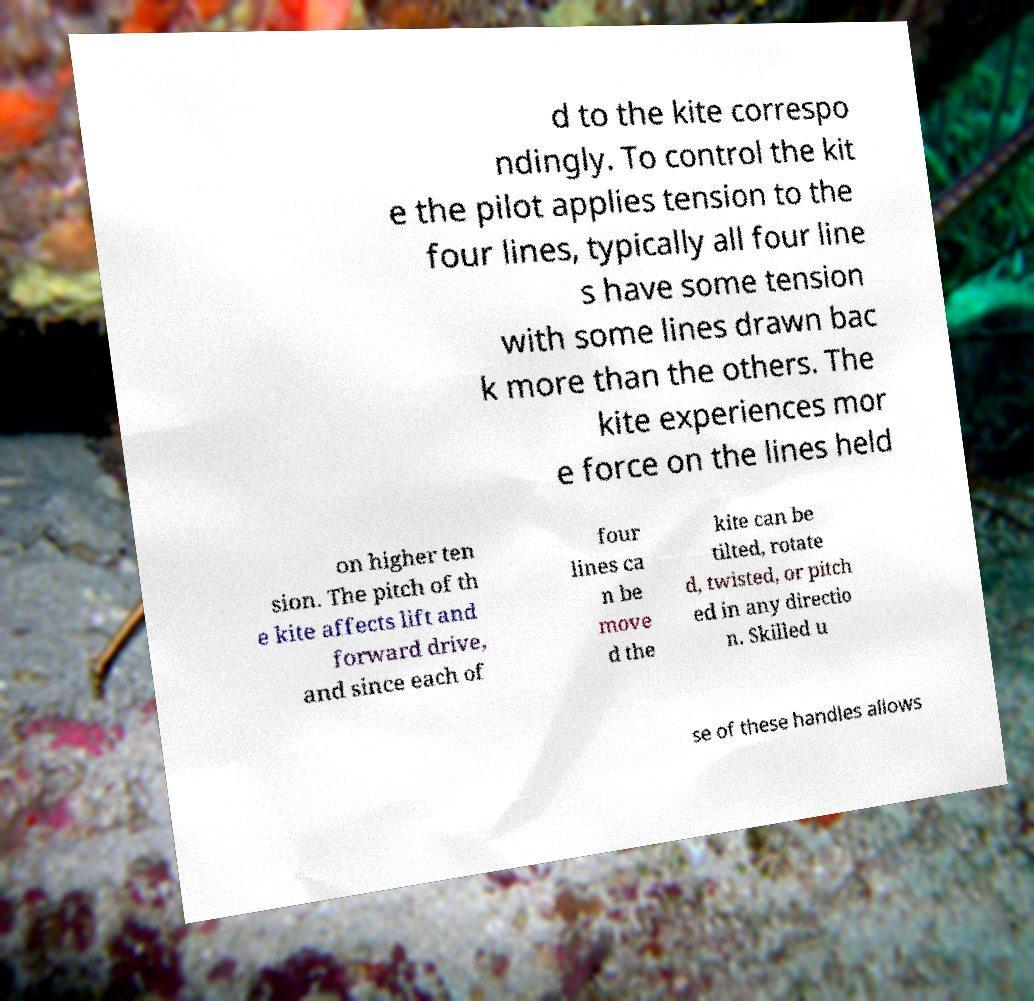Can you read and provide the text displayed in the image?This photo seems to have some interesting text. Can you extract and type it out for me? d to the kite correspo ndingly. To control the kit e the pilot applies tension to the four lines, typically all four line s have some tension with some lines drawn bac k more than the others. The kite experiences mor e force on the lines held on higher ten sion. The pitch of th e kite affects lift and forward drive, and since each of four lines ca n be move d the kite can be tilted, rotate d, twisted, or pitch ed in any directio n. Skilled u se of these handles allows 